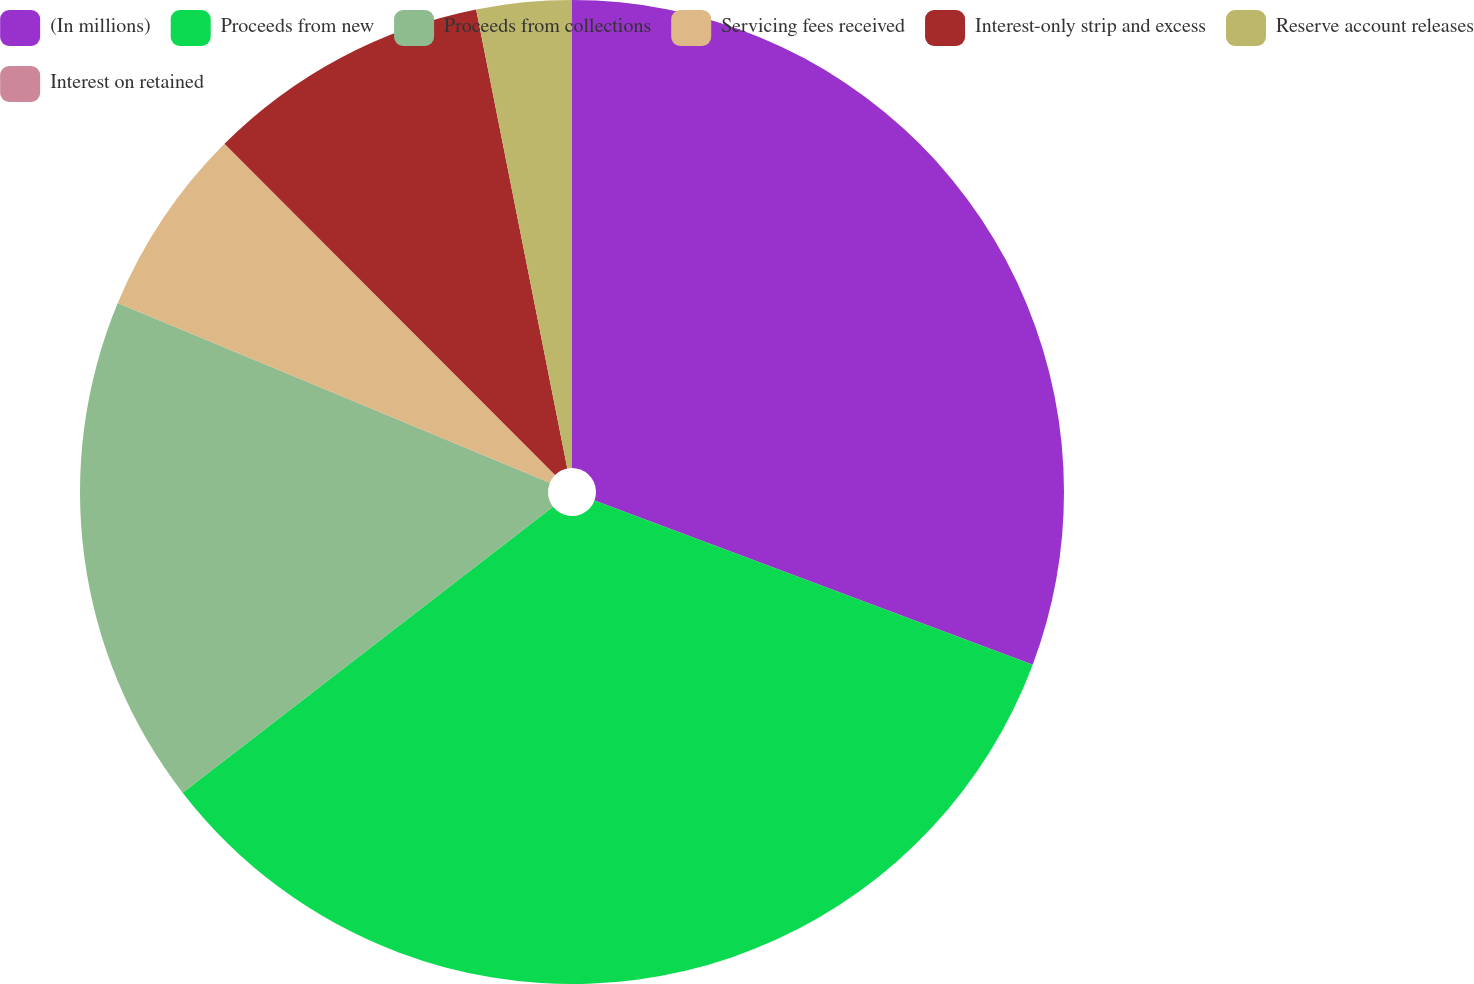<chart> <loc_0><loc_0><loc_500><loc_500><pie_chart><fcel>(In millions)<fcel>Proceeds from new<fcel>Proceeds from collections<fcel>Servicing fees received<fcel>Interest-only strip and excess<fcel>Reserve account releases<fcel>Interest on retained<nl><fcel>30.7%<fcel>33.82%<fcel>16.74%<fcel>6.24%<fcel>9.36%<fcel>3.12%<fcel>0.0%<nl></chart> 